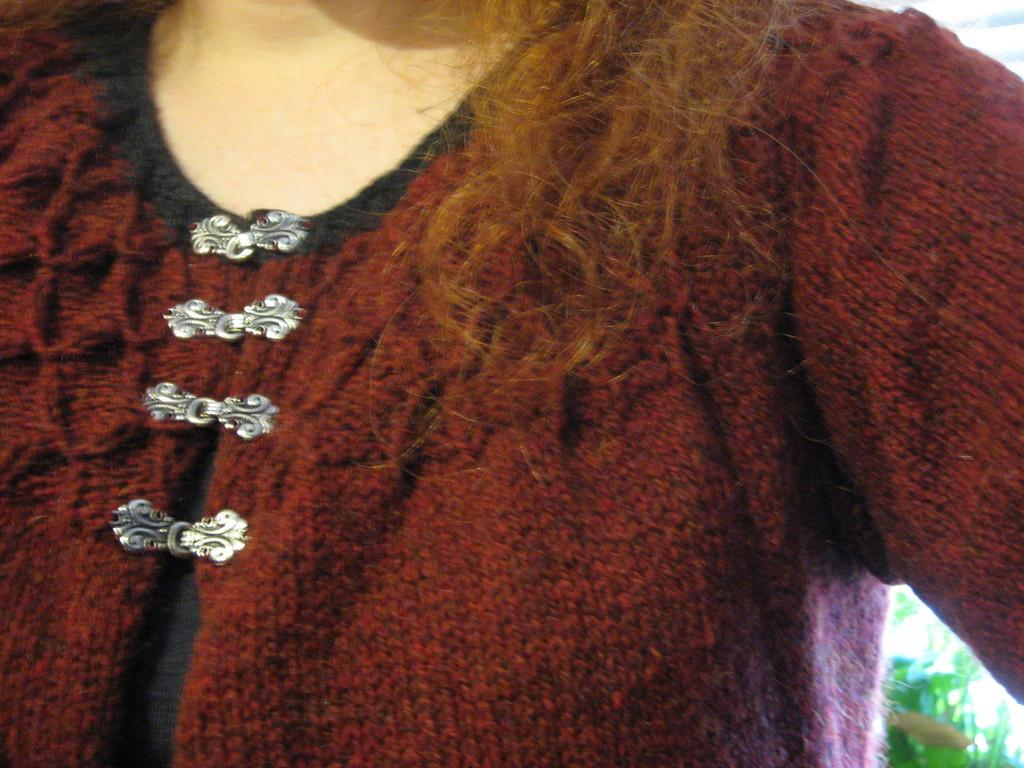Who is the main subject in the image? There is a lady in the center of the image. What type of vegetation can be seen in the image? There is grass in the bottom right side of the image. What type of wing is visible on the lady in the image? There is no wing visible on the lady in the image. What type of grain is being harvested by the farmer in the image? There is no farmer or grain present in the image. 